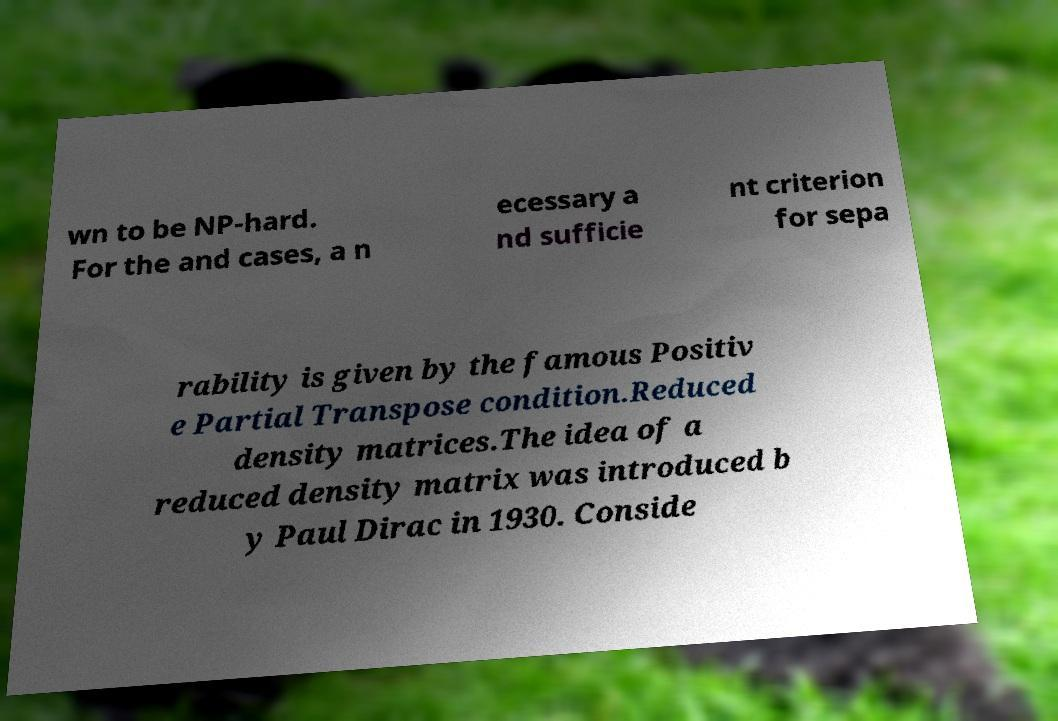For documentation purposes, I need the text within this image transcribed. Could you provide that? wn to be NP-hard. For the and cases, a n ecessary a nd sufficie nt criterion for sepa rability is given by the famous Positiv e Partial Transpose condition.Reduced density matrices.The idea of a reduced density matrix was introduced b y Paul Dirac in 1930. Conside 